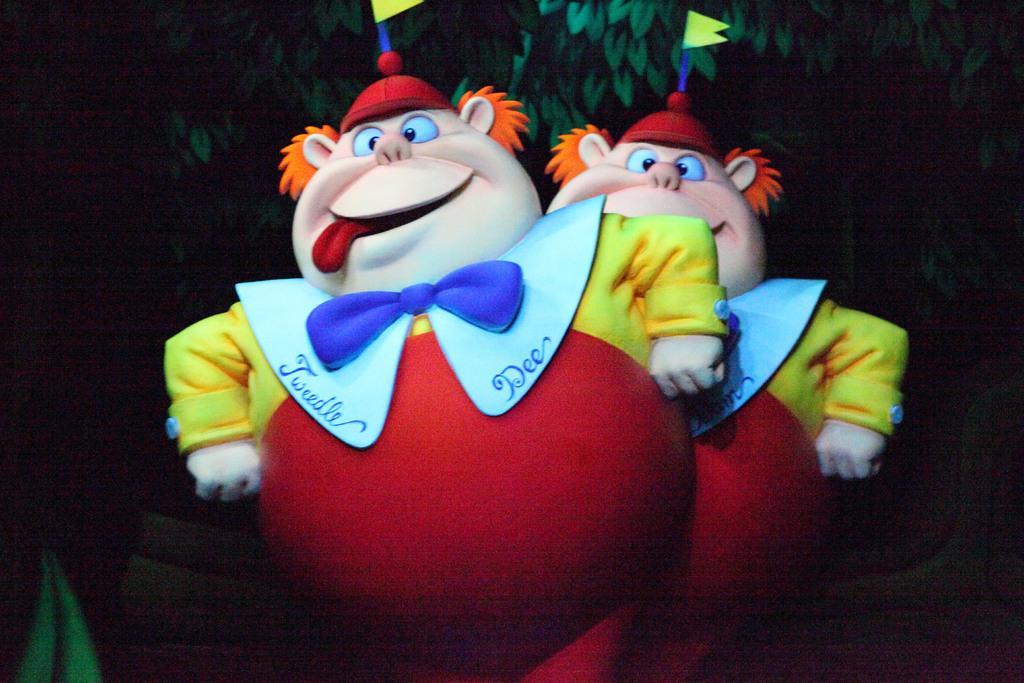How would you summarize this image in a sentence or two? In this picture we can see two toys in the front, in the background we can see some leaves, there is a dark background. 